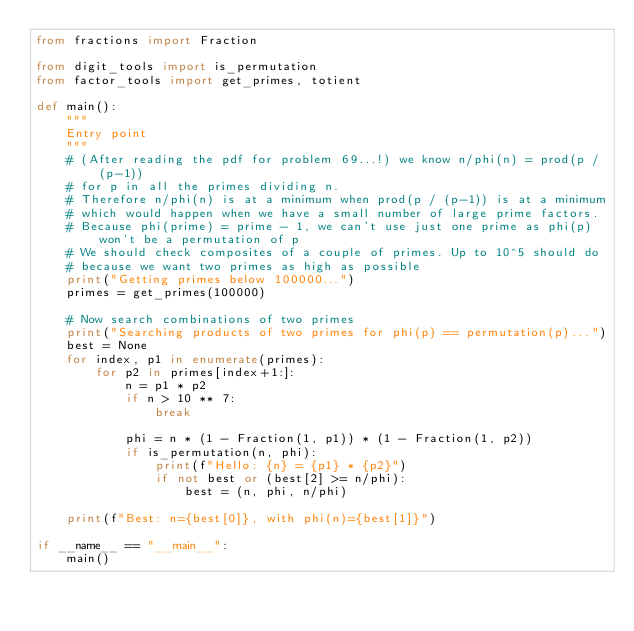<code> <loc_0><loc_0><loc_500><loc_500><_Python_>from fractions import Fraction

from digit_tools import is_permutation
from factor_tools import get_primes, totient

def main():
    """
    Entry point
    """
    # (After reading the pdf for problem 69...!) we know n/phi(n) = prod(p / (p-1))
    # for p in all the primes dividing n.
    # Therefore n/phi(n) is at a minimum when prod(p / (p-1)) is at a minimum
    # which would happen when we have a small number of large prime factors.
    # Because phi(prime) = prime - 1, we can't use just one prime as phi(p) won't be a permutation of p
    # We should check composites of a couple of primes. Up to 10^5 should do
    # because we want two primes as high as possible
    print("Getting primes below 100000...")
    primes = get_primes(100000)
    
    # Now search combinations of two primes 
    print("Searching products of two primes for phi(p) == permutation(p)...")
    best = None
    for index, p1 in enumerate(primes):
        for p2 in primes[index+1:]:
            n = p1 * p2
            if n > 10 ** 7:
                break

            phi = n * (1 - Fraction(1, p1)) * (1 - Fraction(1, p2))
            if is_permutation(n, phi):
                print(f"Hello: {n} = {p1} * {p2}")
                if not best or (best[2] >= n/phi):
                    best = (n, phi, n/phi)

    print(f"Best: n={best[0]}, with phi(n)={best[1]}")

if __name__ == "__main__":
    main()
</code> 